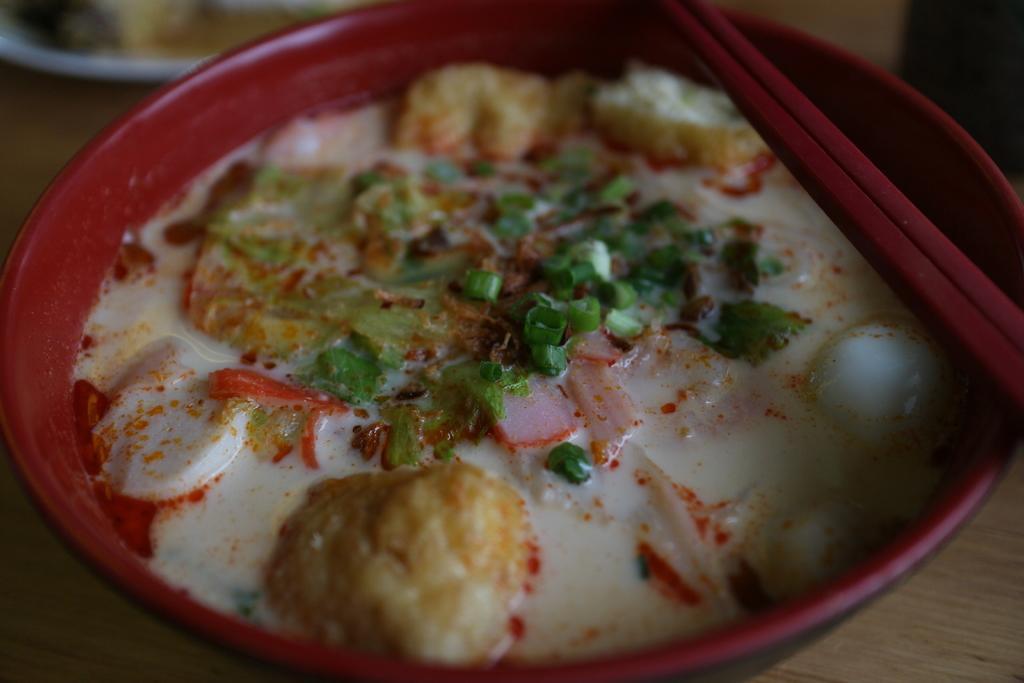In one or two sentences, can you explain what this image depicts? This picture shows food in the bowl and we see couple of chopsticks on it on the table and we see a plate on the side. 